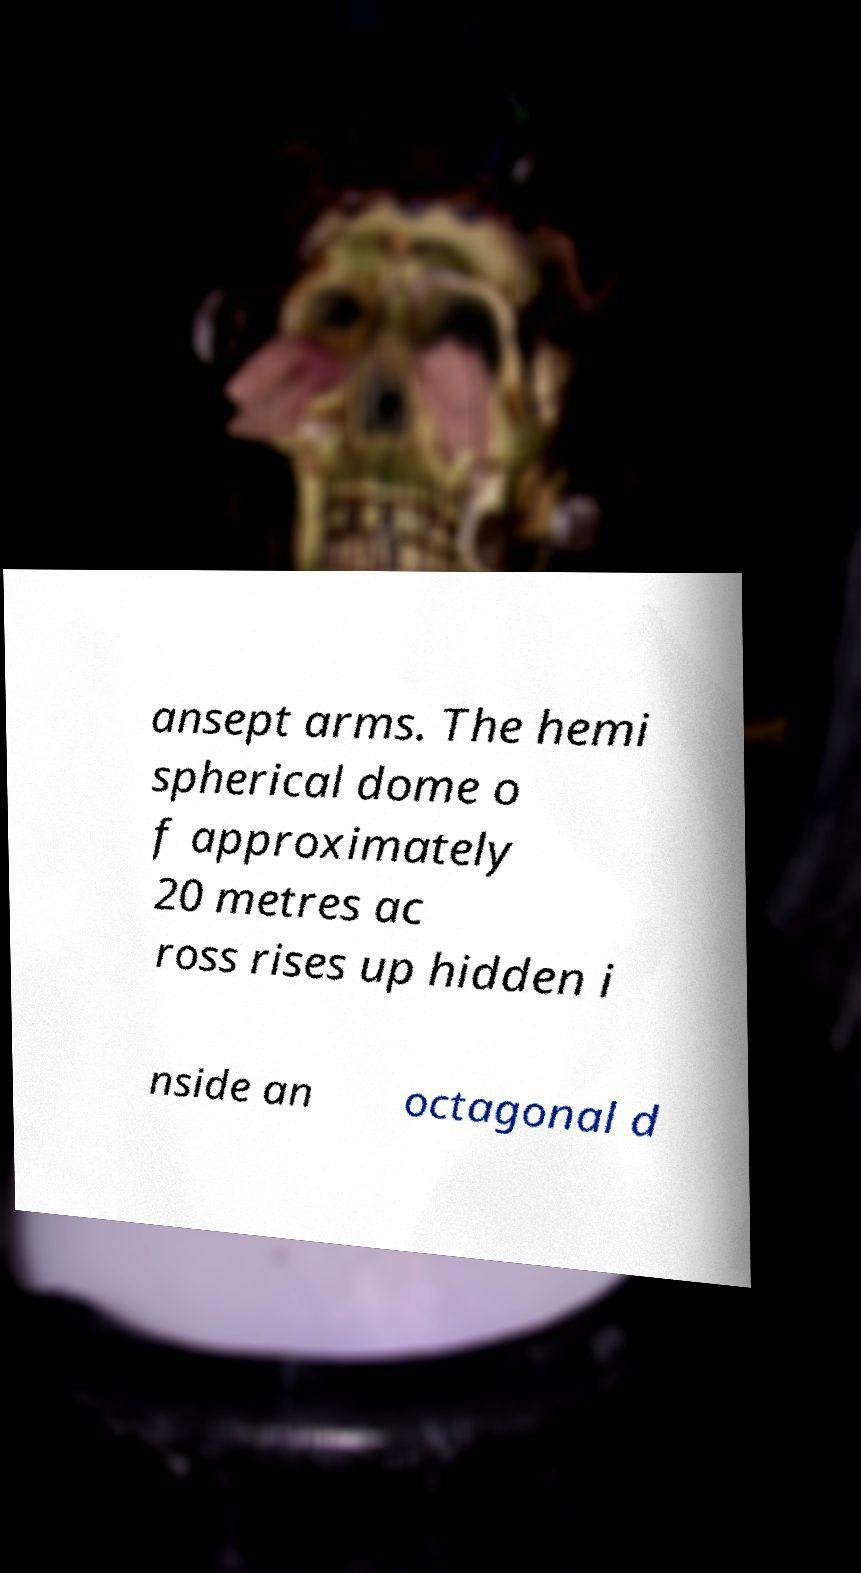I need the written content from this picture converted into text. Can you do that? ansept arms. The hemi spherical dome o f approximately 20 metres ac ross rises up hidden i nside an octagonal d 